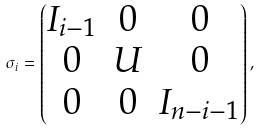<formula> <loc_0><loc_0><loc_500><loc_500>\sigma _ { i } = \begin{pmatrix} I _ { i - 1 } & 0 & 0 \\ 0 & U & 0 \\ 0 & 0 & I _ { n - i - 1 } \end{pmatrix} ,</formula> 